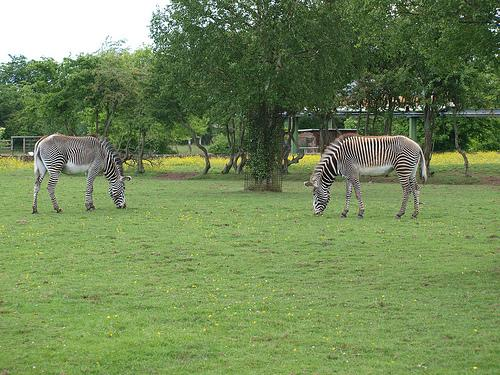What types of flowers can be seen in the picture and where are they located? Yellow flowers are visible in the field, scattered around the grazing zebras. Provide a brief summary of the image content. The image features two zebras grazing on grass in a field surrounded by trees and yellow flowers, with a green fence, a house, and a shade shelter in the background. What type of location does the image appear to be taken in? The image appears to be taken in a wild animal park or a wildlife reserve. What are the primary elements captured in the image? The main elements include two zebras, grass, yellow flowers, trees, wooden fence, house, and the shade shelter. Can you identify the presence of any man-made structures in the image? If so, describe them. Yes, there are a wooden fence, a house, and a shade shelter in the image. Count the number of zebras in the image and describe their activity. There are two zebras in the image, both of them are grazing on grass. Identify any unique patterns present on the zebras in the image. The zebras have black and white striped patterns on their fur and manes. What kind of sentiment does this image evoke? The image evokes a peaceful and serene sentiment with the zebras grazing in a natural environment, surrounded by greenery and flowers. How would you describe the context of the image in terms of weather and time? The image appears to have been taken during daylight, under a clear, sunny sky. Explain the environment surrounding the zebras in the image. The zebras are in a grassy field with yellow flowers scattered around, bordered by trees on one side, and with a wooden fence, a house, and a shade shelter in the background. Mention one unusual or unexpected element in the image. A house behind trees and foliage in the animal compound. Describe the boundaries of the animal compound. Green trees, wooden fence, and a metal fence in the background. What is the predominant color of the surroundings in the image? Green What type of environment do the zebras appear to be in? Wild animal park or wildlife compound. Is there a shade shelter visible in the image? Yes, there is a shade shelter. Is there a large pond in the middle of the field? There is no mention of a pond or any water sources in the given information about the image. What is the position and size of the black and white striped mane of the first zebra? X:74 Y:126 Width:59 Height:59 Is there any significant interaction happening between the two zebras in the image? No, they are mostly grazing and eating grass. Is the zebra with pink stripes standing near the fence? There are no zebras with pink stripes in the image, only black and white striped zebras are mentioned. Provide an assessment of the overall visual quality of the image. The image has a good quality with visible details on subjects and surroundings. What are the two zebras facing in their interaction? Each other with face in the ground. What are the two zebras doing in the image? Grazing and eating green grass. Explain the layout of this wild animal park. The park has an open field with green grass and yellow flowers, green trees bordering the field, a wooden fence, a shade shelter, and a house behind foliage. How many yellow flowers are visible among the green grass? Seven clusters of yellow flowers are visible. Do the zebras have blue eyes? No, it's not mentioned in the image. What is the location and size of the house behind trees and foliage? X:285 Y:66 Width:149 Height:149 Can you find the red flowers in the field? There are no red flowers mentioned in the image, only yellow flowers are present. Describe the main subjects in the image. There are two zebras standing in a field with yellow flowers and a green leaf tree. Analyze the sentiment portrayed by the image. The image has a peaceful and natural atmosphere. List all the objects and their attributes detected in the image. Two zebras (grazing, black and white striped mane, hooves, ear), yellow flowers, green grass, brown tree branches, wooden fence, house, trees in animal compound. Identify the elements that explain the interaction between the two zebras. The two zebras are grazing and facing each other with their faces in the ground. Is the house in the background painted purple? There is no information about the color of the house, so assuming it to be purple is misleading. What type of fence is present in the image? Small brown wooden fence. What is the dominant pattern on the zebras' fur? Black and white striped pattern. Identify the objects in the image with their image. Zebras (X:20 Y:119 Width:412 Height:412), yellow flowers (X:9 Y:226 Width:58 Height:58), tree branches (X:182 Y:133 Width:62 Height:62), wooden fence (X:4 Y:129 Width:58 Height:58), house (X:285 Y:66 Width:149 Height:149). 